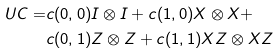Convert formula to latex. <formula><loc_0><loc_0><loc_500><loc_500>\ U C = & c ( 0 , 0 ) I \otimes I + c ( 1 , 0 ) X \otimes X + \\ & c ( 0 , 1 ) Z \otimes Z + c ( 1 , 1 ) X Z \otimes X Z</formula> 